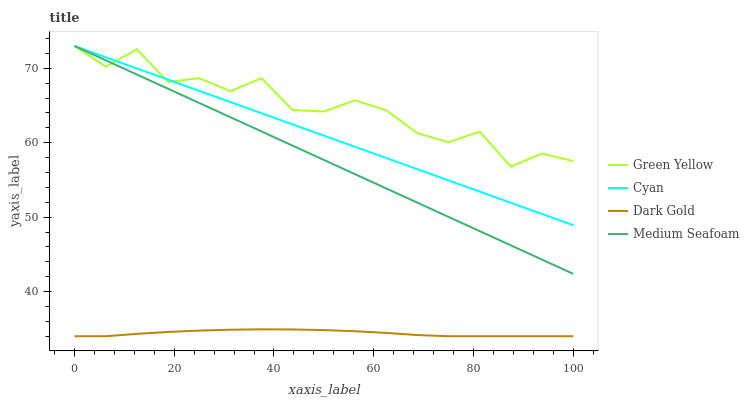Does Dark Gold have the minimum area under the curve?
Answer yes or no. Yes. Does Green Yellow have the maximum area under the curve?
Answer yes or no. Yes. Does Medium Seafoam have the minimum area under the curve?
Answer yes or no. No. Does Medium Seafoam have the maximum area under the curve?
Answer yes or no. No. Is Medium Seafoam the smoothest?
Answer yes or no. Yes. Is Green Yellow the roughest?
Answer yes or no. Yes. Is Green Yellow the smoothest?
Answer yes or no. No. Is Medium Seafoam the roughest?
Answer yes or no. No. Does Medium Seafoam have the lowest value?
Answer yes or no. No. Does Medium Seafoam have the highest value?
Answer yes or no. Yes. Does Dark Gold have the highest value?
Answer yes or no. No. Is Dark Gold less than Cyan?
Answer yes or no. Yes. Is Cyan greater than Dark Gold?
Answer yes or no. Yes. Does Medium Seafoam intersect Cyan?
Answer yes or no. Yes. Is Medium Seafoam less than Cyan?
Answer yes or no. No. Is Medium Seafoam greater than Cyan?
Answer yes or no. No. Does Dark Gold intersect Cyan?
Answer yes or no. No. 